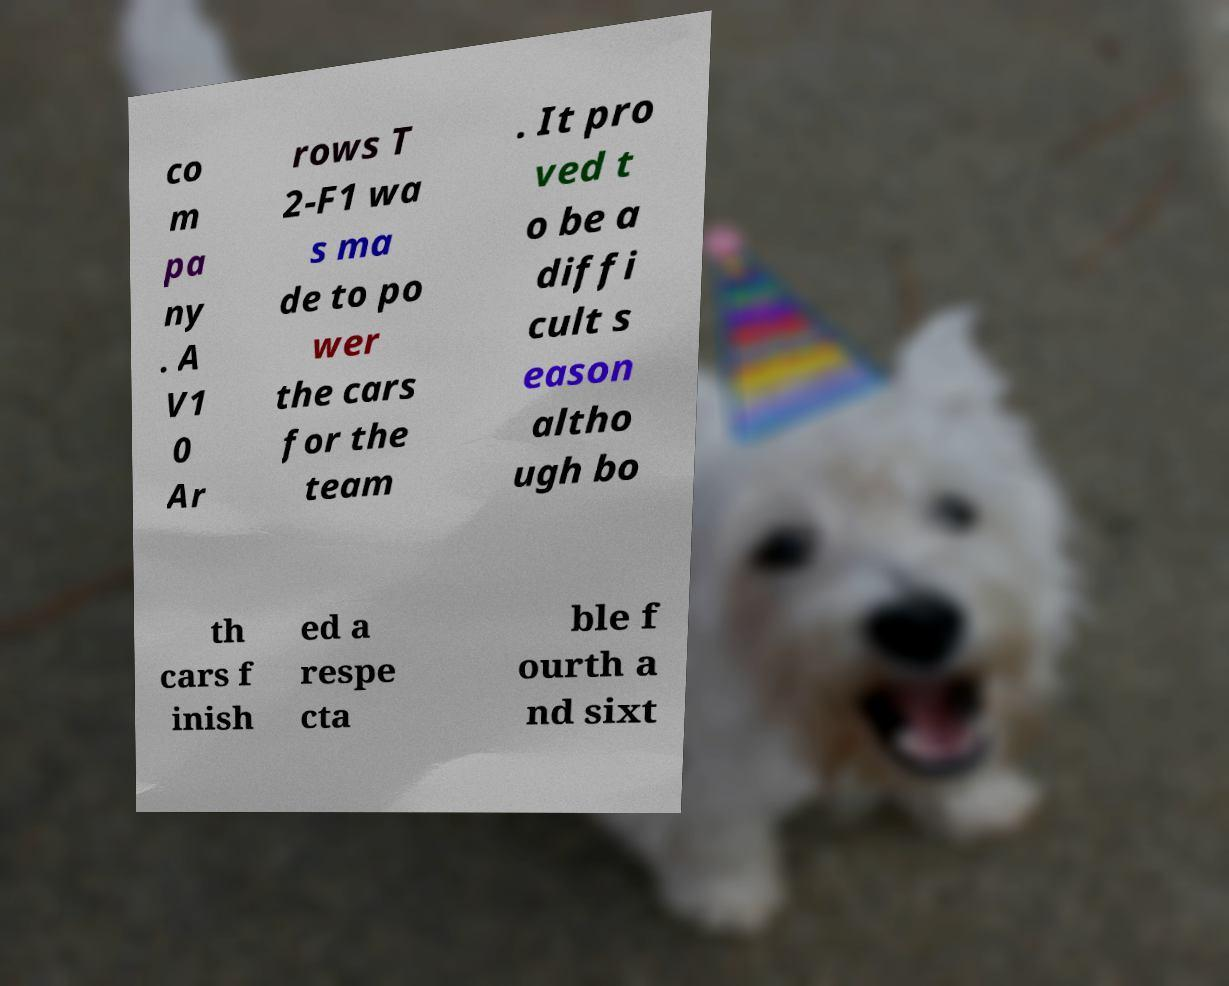Can you read and provide the text displayed in the image?This photo seems to have some interesting text. Can you extract and type it out for me? co m pa ny . A V1 0 Ar rows T 2-F1 wa s ma de to po wer the cars for the team . It pro ved t o be a diffi cult s eason altho ugh bo th cars f inish ed a respe cta ble f ourth a nd sixt 